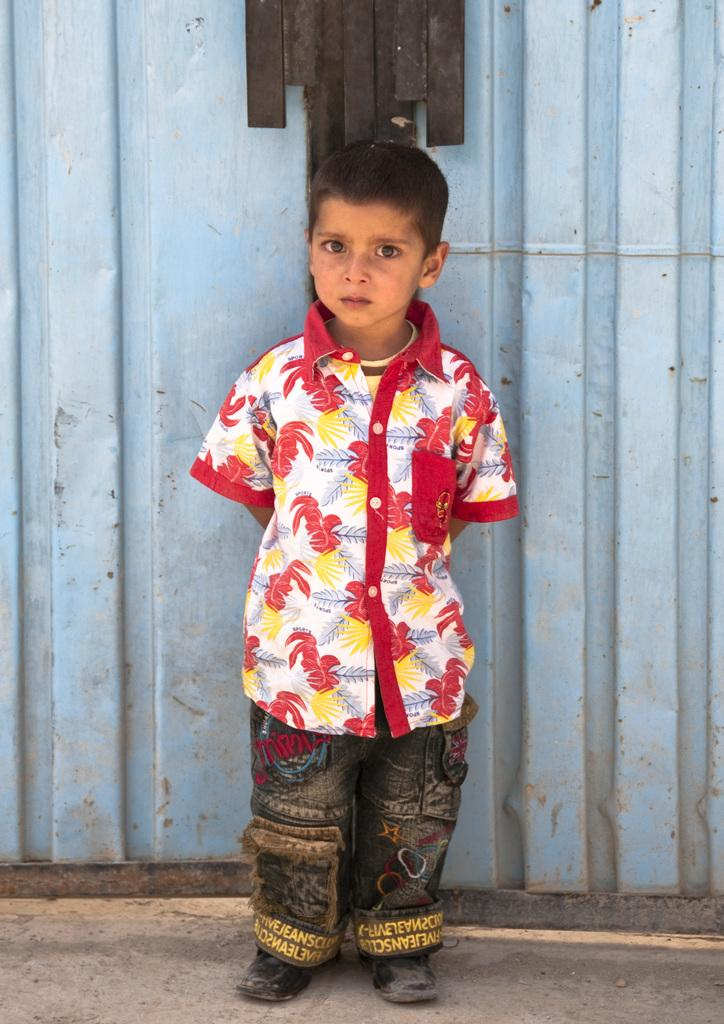What is the main subject of the image? The main subject of the image is a kid. Where is the kid positioned in the image? The kid is standing in the front. What type of clothing is the kid wearing? The kid is wearing a shirt, pants, and shoes. What can be seen in the background of the image? There is a sheet in the background of the image. How many friends is the kid playing with on the hill in the image? There is no hill or friends present in the image; it only features a kid standing in the front. 